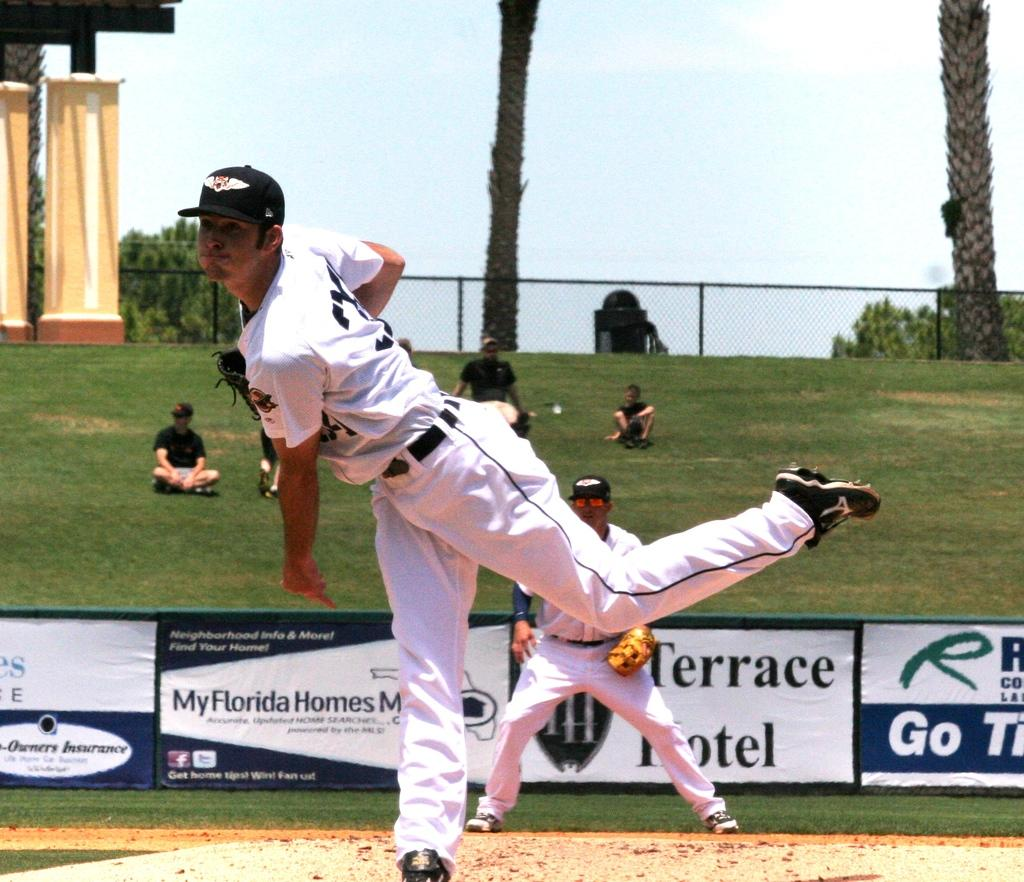Provide a one-sentence caption for the provided image. A man pitches a ball with an ad for Terrace Hotel behind him. 